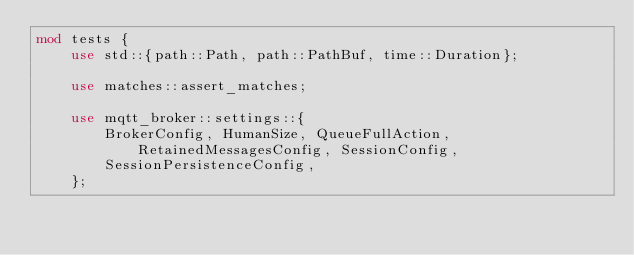<code> <loc_0><loc_0><loc_500><loc_500><_Rust_>mod tests {
    use std::{path::Path, path::PathBuf, time::Duration};

    use matches::assert_matches;

    use mqtt_broker::settings::{
        BrokerConfig, HumanSize, QueueFullAction, RetainedMessagesConfig, SessionConfig,
        SessionPersistenceConfig,
    };
</code> 